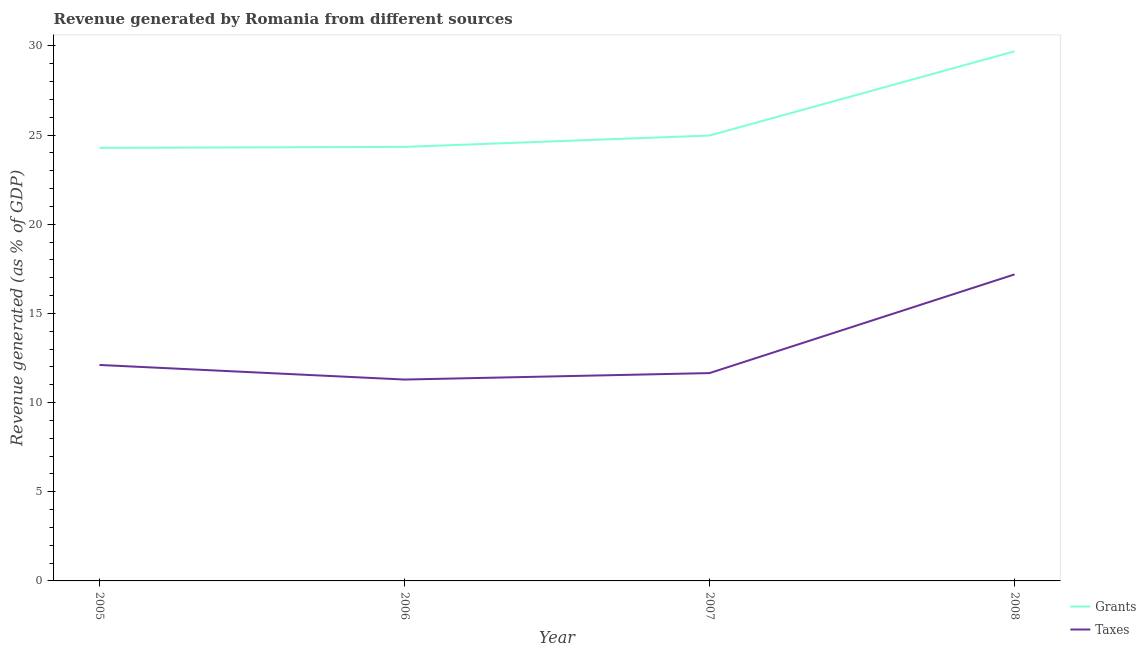How many different coloured lines are there?
Make the answer very short. 2. Does the line corresponding to revenue generated by taxes intersect with the line corresponding to revenue generated by grants?
Make the answer very short. No. What is the revenue generated by grants in 2005?
Keep it short and to the point. 24.29. Across all years, what is the maximum revenue generated by grants?
Offer a terse response. 29.7. Across all years, what is the minimum revenue generated by grants?
Provide a short and direct response. 24.29. In which year was the revenue generated by taxes maximum?
Provide a succinct answer. 2008. What is the total revenue generated by grants in the graph?
Provide a short and direct response. 103.31. What is the difference between the revenue generated by taxes in 2005 and that in 2007?
Offer a terse response. 0.46. What is the difference between the revenue generated by taxes in 2006 and the revenue generated by grants in 2005?
Ensure brevity in your answer.  -12.99. What is the average revenue generated by taxes per year?
Provide a short and direct response. 13.06. In the year 2006, what is the difference between the revenue generated by grants and revenue generated by taxes?
Ensure brevity in your answer.  13.05. In how many years, is the revenue generated by grants greater than 9 %?
Provide a succinct answer. 4. What is the ratio of the revenue generated by grants in 2005 to that in 2007?
Keep it short and to the point. 0.97. Is the difference between the revenue generated by taxes in 2005 and 2008 greater than the difference between the revenue generated by grants in 2005 and 2008?
Give a very brief answer. Yes. What is the difference between the highest and the second highest revenue generated by grants?
Offer a terse response. 4.72. What is the difference between the highest and the lowest revenue generated by grants?
Offer a terse response. 5.42. In how many years, is the revenue generated by taxes greater than the average revenue generated by taxes taken over all years?
Your answer should be very brief. 1. Is the sum of the revenue generated by grants in 2006 and 2007 greater than the maximum revenue generated by taxes across all years?
Offer a terse response. Yes. Is the revenue generated by taxes strictly greater than the revenue generated by grants over the years?
Provide a short and direct response. No. How many years are there in the graph?
Make the answer very short. 4. What is the difference between two consecutive major ticks on the Y-axis?
Keep it short and to the point. 5. Does the graph contain grids?
Offer a very short reply. No. How many legend labels are there?
Provide a short and direct response. 2. What is the title of the graph?
Provide a short and direct response. Revenue generated by Romania from different sources. What is the label or title of the Y-axis?
Give a very brief answer. Revenue generated (as % of GDP). What is the Revenue generated (as % of GDP) of Grants in 2005?
Offer a very short reply. 24.29. What is the Revenue generated (as % of GDP) in Taxes in 2005?
Your response must be concise. 12.11. What is the Revenue generated (as % of GDP) in Grants in 2006?
Give a very brief answer. 24.34. What is the Revenue generated (as % of GDP) of Taxes in 2006?
Make the answer very short. 11.29. What is the Revenue generated (as % of GDP) in Grants in 2007?
Your answer should be very brief. 24.98. What is the Revenue generated (as % of GDP) in Taxes in 2007?
Give a very brief answer. 11.66. What is the Revenue generated (as % of GDP) of Grants in 2008?
Provide a short and direct response. 29.7. What is the Revenue generated (as % of GDP) in Taxes in 2008?
Make the answer very short. 17.19. Across all years, what is the maximum Revenue generated (as % of GDP) of Grants?
Offer a very short reply. 29.7. Across all years, what is the maximum Revenue generated (as % of GDP) in Taxes?
Keep it short and to the point. 17.19. Across all years, what is the minimum Revenue generated (as % of GDP) of Grants?
Make the answer very short. 24.29. Across all years, what is the minimum Revenue generated (as % of GDP) of Taxes?
Your answer should be compact. 11.29. What is the total Revenue generated (as % of GDP) in Grants in the graph?
Ensure brevity in your answer.  103.31. What is the total Revenue generated (as % of GDP) in Taxes in the graph?
Keep it short and to the point. 52.25. What is the difference between the Revenue generated (as % of GDP) of Grants in 2005 and that in 2006?
Provide a short and direct response. -0.05. What is the difference between the Revenue generated (as % of GDP) in Taxes in 2005 and that in 2006?
Offer a terse response. 0.82. What is the difference between the Revenue generated (as % of GDP) in Grants in 2005 and that in 2007?
Give a very brief answer. -0.69. What is the difference between the Revenue generated (as % of GDP) in Taxes in 2005 and that in 2007?
Give a very brief answer. 0.46. What is the difference between the Revenue generated (as % of GDP) of Grants in 2005 and that in 2008?
Offer a very short reply. -5.42. What is the difference between the Revenue generated (as % of GDP) of Taxes in 2005 and that in 2008?
Ensure brevity in your answer.  -5.08. What is the difference between the Revenue generated (as % of GDP) in Grants in 2006 and that in 2007?
Your response must be concise. -0.64. What is the difference between the Revenue generated (as % of GDP) of Taxes in 2006 and that in 2007?
Offer a very short reply. -0.36. What is the difference between the Revenue generated (as % of GDP) of Grants in 2006 and that in 2008?
Make the answer very short. -5.36. What is the difference between the Revenue generated (as % of GDP) of Taxes in 2006 and that in 2008?
Keep it short and to the point. -5.9. What is the difference between the Revenue generated (as % of GDP) in Grants in 2007 and that in 2008?
Ensure brevity in your answer.  -4.72. What is the difference between the Revenue generated (as % of GDP) of Taxes in 2007 and that in 2008?
Keep it short and to the point. -5.54. What is the difference between the Revenue generated (as % of GDP) of Grants in 2005 and the Revenue generated (as % of GDP) of Taxes in 2006?
Keep it short and to the point. 12.99. What is the difference between the Revenue generated (as % of GDP) in Grants in 2005 and the Revenue generated (as % of GDP) in Taxes in 2007?
Offer a very short reply. 12.63. What is the difference between the Revenue generated (as % of GDP) of Grants in 2005 and the Revenue generated (as % of GDP) of Taxes in 2008?
Make the answer very short. 7.1. What is the difference between the Revenue generated (as % of GDP) of Grants in 2006 and the Revenue generated (as % of GDP) of Taxes in 2007?
Provide a short and direct response. 12.69. What is the difference between the Revenue generated (as % of GDP) in Grants in 2006 and the Revenue generated (as % of GDP) in Taxes in 2008?
Provide a succinct answer. 7.15. What is the difference between the Revenue generated (as % of GDP) in Grants in 2007 and the Revenue generated (as % of GDP) in Taxes in 2008?
Give a very brief answer. 7.79. What is the average Revenue generated (as % of GDP) in Grants per year?
Make the answer very short. 25.83. What is the average Revenue generated (as % of GDP) of Taxes per year?
Make the answer very short. 13.06. In the year 2005, what is the difference between the Revenue generated (as % of GDP) in Grants and Revenue generated (as % of GDP) in Taxes?
Offer a terse response. 12.17. In the year 2006, what is the difference between the Revenue generated (as % of GDP) in Grants and Revenue generated (as % of GDP) in Taxes?
Ensure brevity in your answer.  13.05. In the year 2007, what is the difference between the Revenue generated (as % of GDP) in Grants and Revenue generated (as % of GDP) in Taxes?
Offer a terse response. 13.32. In the year 2008, what is the difference between the Revenue generated (as % of GDP) in Grants and Revenue generated (as % of GDP) in Taxes?
Offer a very short reply. 12.51. What is the ratio of the Revenue generated (as % of GDP) in Taxes in 2005 to that in 2006?
Offer a very short reply. 1.07. What is the ratio of the Revenue generated (as % of GDP) in Grants in 2005 to that in 2007?
Keep it short and to the point. 0.97. What is the ratio of the Revenue generated (as % of GDP) of Taxes in 2005 to that in 2007?
Your response must be concise. 1.04. What is the ratio of the Revenue generated (as % of GDP) of Grants in 2005 to that in 2008?
Your answer should be very brief. 0.82. What is the ratio of the Revenue generated (as % of GDP) in Taxes in 2005 to that in 2008?
Offer a very short reply. 0.7. What is the ratio of the Revenue generated (as % of GDP) of Grants in 2006 to that in 2007?
Keep it short and to the point. 0.97. What is the ratio of the Revenue generated (as % of GDP) of Taxes in 2006 to that in 2007?
Ensure brevity in your answer.  0.97. What is the ratio of the Revenue generated (as % of GDP) in Grants in 2006 to that in 2008?
Offer a very short reply. 0.82. What is the ratio of the Revenue generated (as % of GDP) of Taxes in 2006 to that in 2008?
Your response must be concise. 0.66. What is the ratio of the Revenue generated (as % of GDP) of Grants in 2007 to that in 2008?
Your response must be concise. 0.84. What is the ratio of the Revenue generated (as % of GDP) of Taxes in 2007 to that in 2008?
Provide a short and direct response. 0.68. What is the difference between the highest and the second highest Revenue generated (as % of GDP) of Grants?
Offer a terse response. 4.72. What is the difference between the highest and the second highest Revenue generated (as % of GDP) of Taxes?
Offer a very short reply. 5.08. What is the difference between the highest and the lowest Revenue generated (as % of GDP) in Grants?
Offer a very short reply. 5.42. What is the difference between the highest and the lowest Revenue generated (as % of GDP) in Taxes?
Keep it short and to the point. 5.9. 